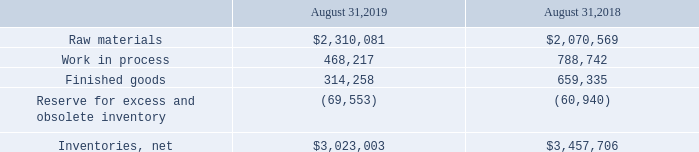3. Inventories
Inventories consist of the following (in thousands):
Which years does the table provide information for inventories? 2019, 2018. What was the amount of finished goods in 2019?
Answer scale should be: thousand. 314,258. What was the amount of work in process in 2018?
Answer scale should be: thousand. 788,742. What was the change in finished goods between 2018 and 2019?
Answer scale should be: thousand. 314,258-659,335
Answer: -345077. What was the change in work in process between 2018 and 2019?
Answer scale should be: thousand. 468,217-788,742
Answer: -320525. What was the percentage change in raw materials between 2018 and 2019?
Answer scale should be: percent. ($2,310,081-$2,070,569)/$2,070,569
Answer: 11.57. 